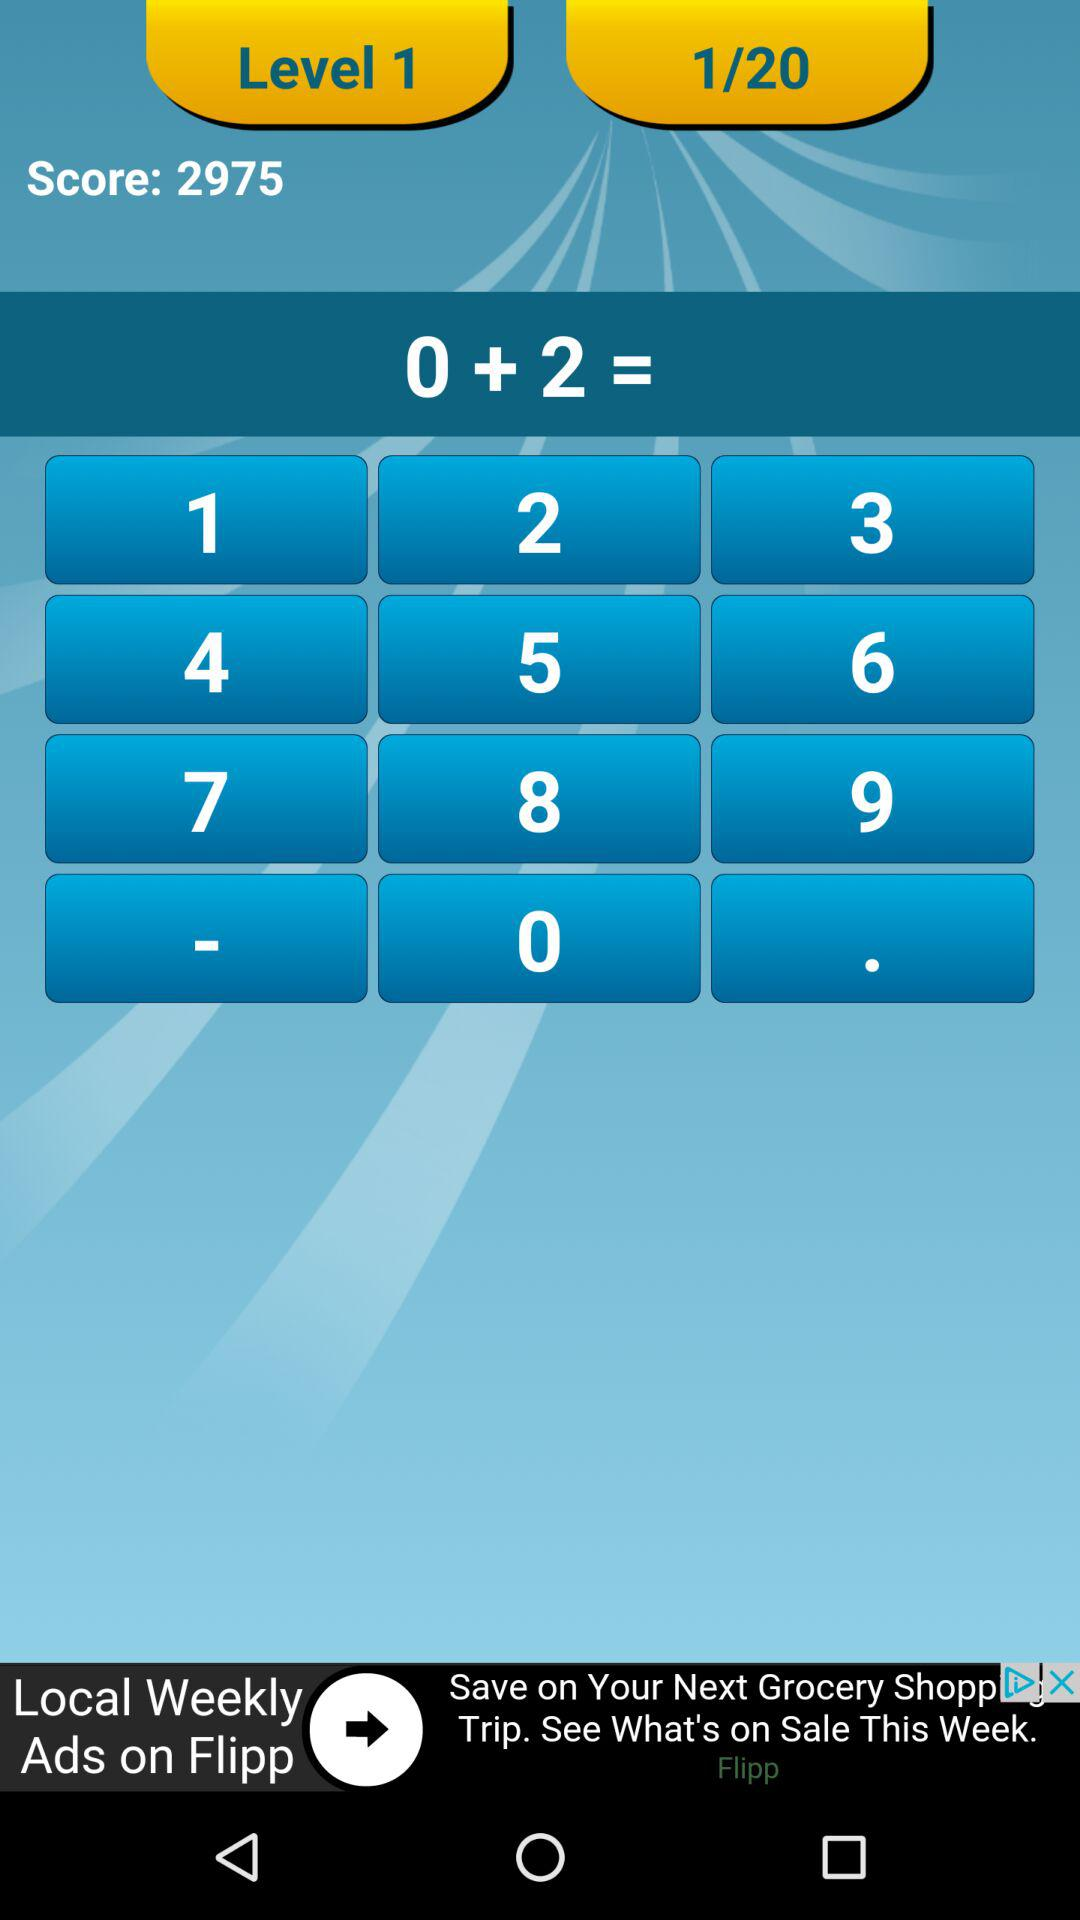What is the score on the screen?
Answer the question using a single word or phrase. 2975 